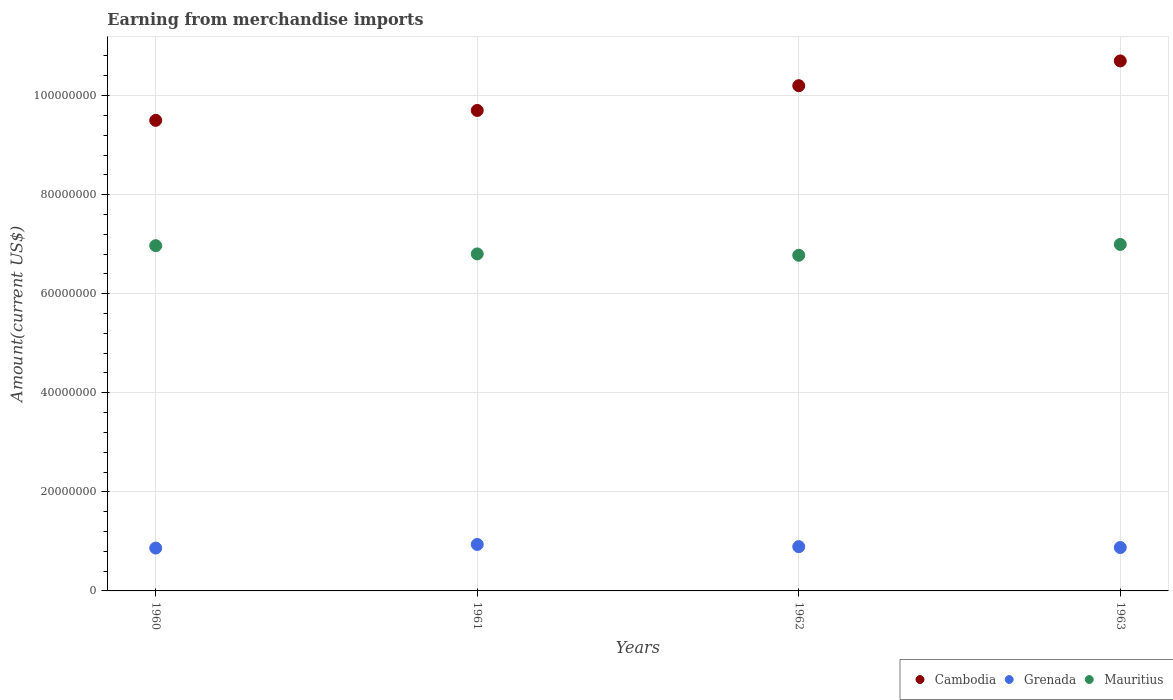How many different coloured dotlines are there?
Offer a very short reply. 3. What is the amount earned from merchandise imports in Mauritius in 1960?
Provide a short and direct response. 6.97e+07. Across all years, what is the maximum amount earned from merchandise imports in Cambodia?
Your answer should be very brief. 1.07e+08. Across all years, what is the minimum amount earned from merchandise imports in Cambodia?
Your answer should be compact. 9.50e+07. In which year was the amount earned from merchandise imports in Mauritius maximum?
Ensure brevity in your answer.  1963. What is the total amount earned from merchandise imports in Grenada in the graph?
Provide a succinct answer. 3.57e+07. What is the difference between the amount earned from merchandise imports in Cambodia in 1960 and that in 1963?
Your answer should be very brief. -1.20e+07. What is the difference between the amount earned from merchandise imports in Grenada in 1962 and the amount earned from merchandise imports in Cambodia in 1963?
Give a very brief answer. -9.81e+07. What is the average amount earned from merchandise imports in Cambodia per year?
Your response must be concise. 1.00e+08. In the year 1960, what is the difference between the amount earned from merchandise imports in Mauritius and amount earned from merchandise imports in Grenada?
Provide a short and direct response. 6.10e+07. In how many years, is the amount earned from merchandise imports in Cambodia greater than 100000000 US$?
Provide a short and direct response. 2. What is the ratio of the amount earned from merchandise imports in Cambodia in 1960 to that in 1961?
Provide a succinct answer. 0.98. Is the amount earned from merchandise imports in Cambodia in 1961 less than that in 1963?
Keep it short and to the point. Yes. What is the difference between the highest and the second highest amount earned from merchandise imports in Mauritius?
Provide a succinct answer. 2.52e+05. What is the difference between the highest and the lowest amount earned from merchandise imports in Mauritius?
Offer a very short reply. 2.18e+06. In how many years, is the amount earned from merchandise imports in Cambodia greater than the average amount earned from merchandise imports in Cambodia taken over all years?
Your response must be concise. 2. Is the sum of the amount earned from merchandise imports in Grenada in 1960 and 1962 greater than the maximum amount earned from merchandise imports in Cambodia across all years?
Your response must be concise. No. Does the amount earned from merchandise imports in Mauritius monotonically increase over the years?
Offer a terse response. No. Is the amount earned from merchandise imports in Grenada strictly greater than the amount earned from merchandise imports in Cambodia over the years?
Offer a very short reply. No. Is the amount earned from merchandise imports in Mauritius strictly less than the amount earned from merchandise imports in Cambodia over the years?
Make the answer very short. Yes. How many dotlines are there?
Keep it short and to the point. 3. What is the difference between two consecutive major ticks on the Y-axis?
Offer a terse response. 2.00e+07. Does the graph contain any zero values?
Offer a terse response. No. How many legend labels are there?
Your answer should be compact. 3. How are the legend labels stacked?
Offer a very short reply. Horizontal. What is the title of the graph?
Give a very brief answer. Earning from merchandise imports. Does "Uruguay" appear as one of the legend labels in the graph?
Your answer should be compact. No. What is the label or title of the X-axis?
Provide a short and direct response. Years. What is the label or title of the Y-axis?
Your response must be concise. Amount(current US$). What is the Amount(current US$) in Cambodia in 1960?
Provide a short and direct response. 9.50e+07. What is the Amount(current US$) in Grenada in 1960?
Provide a succinct answer. 8.65e+06. What is the Amount(current US$) of Mauritius in 1960?
Offer a terse response. 6.97e+07. What is the Amount(current US$) in Cambodia in 1961?
Provide a short and direct response. 9.70e+07. What is the Amount(current US$) in Grenada in 1961?
Provide a succinct answer. 9.38e+06. What is the Amount(current US$) in Mauritius in 1961?
Make the answer very short. 6.80e+07. What is the Amount(current US$) in Cambodia in 1962?
Your response must be concise. 1.02e+08. What is the Amount(current US$) of Grenada in 1962?
Your response must be concise. 8.94e+06. What is the Amount(current US$) of Mauritius in 1962?
Offer a terse response. 6.78e+07. What is the Amount(current US$) of Cambodia in 1963?
Keep it short and to the point. 1.07e+08. What is the Amount(current US$) in Grenada in 1963?
Your answer should be compact. 8.76e+06. What is the Amount(current US$) of Mauritius in 1963?
Keep it short and to the point. 7.00e+07. Across all years, what is the maximum Amount(current US$) in Cambodia?
Keep it short and to the point. 1.07e+08. Across all years, what is the maximum Amount(current US$) in Grenada?
Ensure brevity in your answer.  9.38e+06. Across all years, what is the maximum Amount(current US$) in Mauritius?
Your response must be concise. 7.00e+07. Across all years, what is the minimum Amount(current US$) of Cambodia?
Your response must be concise. 9.50e+07. Across all years, what is the minimum Amount(current US$) of Grenada?
Make the answer very short. 8.65e+06. Across all years, what is the minimum Amount(current US$) of Mauritius?
Offer a very short reply. 6.78e+07. What is the total Amount(current US$) of Cambodia in the graph?
Ensure brevity in your answer.  4.01e+08. What is the total Amount(current US$) of Grenada in the graph?
Provide a succinct answer. 3.57e+07. What is the total Amount(current US$) in Mauritius in the graph?
Your answer should be very brief. 2.75e+08. What is the difference between the Amount(current US$) in Grenada in 1960 and that in 1961?
Your answer should be very brief. -7.30e+05. What is the difference between the Amount(current US$) in Mauritius in 1960 and that in 1961?
Your answer should be compact. 1.66e+06. What is the difference between the Amount(current US$) of Cambodia in 1960 and that in 1962?
Ensure brevity in your answer.  -7.00e+06. What is the difference between the Amount(current US$) of Grenada in 1960 and that in 1962?
Your answer should be compact. -2.84e+05. What is the difference between the Amount(current US$) of Mauritius in 1960 and that in 1962?
Your response must be concise. 1.93e+06. What is the difference between the Amount(current US$) in Cambodia in 1960 and that in 1963?
Your response must be concise. -1.20e+07. What is the difference between the Amount(current US$) of Grenada in 1960 and that in 1963?
Provide a succinct answer. -1.12e+05. What is the difference between the Amount(current US$) of Mauritius in 1960 and that in 1963?
Your response must be concise. -2.52e+05. What is the difference between the Amount(current US$) of Cambodia in 1961 and that in 1962?
Your answer should be very brief. -5.00e+06. What is the difference between the Amount(current US$) of Grenada in 1961 and that in 1962?
Keep it short and to the point. 4.46e+05. What is the difference between the Amount(current US$) in Mauritius in 1961 and that in 1962?
Give a very brief answer. 2.73e+05. What is the difference between the Amount(current US$) in Cambodia in 1961 and that in 1963?
Provide a succinct answer. -1.00e+07. What is the difference between the Amount(current US$) of Grenada in 1961 and that in 1963?
Provide a succinct answer. 6.18e+05. What is the difference between the Amount(current US$) in Mauritius in 1961 and that in 1963?
Offer a very short reply. -1.91e+06. What is the difference between the Amount(current US$) in Cambodia in 1962 and that in 1963?
Your response must be concise. -5.00e+06. What is the difference between the Amount(current US$) of Grenada in 1962 and that in 1963?
Provide a succinct answer. 1.72e+05. What is the difference between the Amount(current US$) of Mauritius in 1962 and that in 1963?
Ensure brevity in your answer.  -2.18e+06. What is the difference between the Amount(current US$) of Cambodia in 1960 and the Amount(current US$) of Grenada in 1961?
Give a very brief answer. 8.56e+07. What is the difference between the Amount(current US$) in Cambodia in 1960 and the Amount(current US$) in Mauritius in 1961?
Provide a succinct answer. 2.70e+07. What is the difference between the Amount(current US$) in Grenada in 1960 and the Amount(current US$) in Mauritius in 1961?
Provide a short and direct response. -5.94e+07. What is the difference between the Amount(current US$) in Cambodia in 1960 and the Amount(current US$) in Grenada in 1962?
Ensure brevity in your answer.  8.61e+07. What is the difference between the Amount(current US$) of Cambodia in 1960 and the Amount(current US$) of Mauritius in 1962?
Provide a succinct answer. 2.72e+07. What is the difference between the Amount(current US$) in Grenada in 1960 and the Amount(current US$) in Mauritius in 1962?
Give a very brief answer. -5.91e+07. What is the difference between the Amount(current US$) of Cambodia in 1960 and the Amount(current US$) of Grenada in 1963?
Your answer should be very brief. 8.62e+07. What is the difference between the Amount(current US$) of Cambodia in 1960 and the Amount(current US$) of Mauritius in 1963?
Your answer should be very brief. 2.50e+07. What is the difference between the Amount(current US$) in Grenada in 1960 and the Amount(current US$) in Mauritius in 1963?
Offer a terse response. -6.13e+07. What is the difference between the Amount(current US$) in Cambodia in 1961 and the Amount(current US$) in Grenada in 1962?
Make the answer very short. 8.81e+07. What is the difference between the Amount(current US$) of Cambodia in 1961 and the Amount(current US$) of Mauritius in 1962?
Your answer should be very brief. 2.92e+07. What is the difference between the Amount(current US$) of Grenada in 1961 and the Amount(current US$) of Mauritius in 1962?
Ensure brevity in your answer.  -5.84e+07. What is the difference between the Amount(current US$) of Cambodia in 1961 and the Amount(current US$) of Grenada in 1963?
Offer a very short reply. 8.82e+07. What is the difference between the Amount(current US$) in Cambodia in 1961 and the Amount(current US$) in Mauritius in 1963?
Give a very brief answer. 2.70e+07. What is the difference between the Amount(current US$) of Grenada in 1961 and the Amount(current US$) of Mauritius in 1963?
Ensure brevity in your answer.  -6.06e+07. What is the difference between the Amount(current US$) of Cambodia in 1962 and the Amount(current US$) of Grenada in 1963?
Your answer should be compact. 9.32e+07. What is the difference between the Amount(current US$) in Cambodia in 1962 and the Amount(current US$) in Mauritius in 1963?
Provide a short and direct response. 3.20e+07. What is the difference between the Amount(current US$) in Grenada in 1962 and the Amount(current US$) in Mauritius in 1963?
Ensure brevity in your answer.  -6.10e+07. What is the average Amount(current US$) of Cambodia per year?
Make the answer very short. 1.00e+08. What is the average Amount(current US$) in Grenada per year?
Keep it short and to the point. 8.93e+06. What is the average Amount(current US$) of Mauritius per year?
Give a very brief answer. 6.89e+07. In the year 1960, what is the difference between the Amount(current US$) in Cambodia and Amount(current US$) in Grenada?
Keep it short and to the point. 8.63e+07. In the year 1960, what is the difference between the Amount(current US$) in Cambodia and Amount(current US$) in Mauritius?
Your answer should be very brief. 2.53e+07. In the year 1960, what is the difference between the Amount(current US$) in Grenada and Amount(current US$) in Mauritius?
Offer a terse response. -6.10e+07. In the year 1961, what is the difference between the Amount(current US$) of Cambodia and Amount(current US$) of Grenada?
Make the answer very short. 8.76e+07. In the year 1961, what is the difference between the Amount(current US$) of Cambodia and Amount(current US$) of Mauritius?
Provide a succinct answer. 2.90e+07. In the year 1961, what is the difference between the Amount(current US$) in Grenada and Amount(current US$) in Mauritius?
Ensure brevity in your answer.  -5.87e+07. In the year 1962, what is the difference between the Amount(current US$) of Cambodia and Amount(current US$) of Grenada?
Your answer should be very brief. 9.31e+07. In the year 1962, what is the difference between the Amount(current US$) of Cambodia and Amount(current US$) of Mauritius?
Provide a short and direct response. 3.42e+07. In the year 1962, what is the difference between the Amount(current US$) in Grenada and Amount(current US$) in Mauritius?
Offer a very short reply. -5.88e+07. In the year 1963, what is the difference between the Amount(current US$) of Cambodia and Amount(current US$) of Grenada?
Make the answer very short. 9.82e+07. In the year 1963, what is the difference between the Amount(current US$) of Cambodia and Amount(current US$) of Mauritius?
Your response must be concise. 3.70e+07. In the year 1963, what is the difference between the Amount(current US$) in Grenada and Amount(current US$) in Mauritius?
Give a very brief answer. -6.12e+07. What is the ratio of the Amount(current US$) in Cambodia in 1960 to that in 1961?
Make the answer very short. 0.98. What is the ratio of the Amount(current US$) in Grenada in 1960 to that in 1961?
Your answer should be compact. 0.92. What is the ratio of the Amount(current US$) of Mauritius in 1960 to that in 1961?
Ensure brevity in your answer.  1.02. What is the ratio of the Amount(current US$) of Cambodia in 1960 to that in 1962?
Ensure brevity in your answer.  0.93. What is the ratio of the Amount(current US$) of Grenada in 1960 to that in 1962?
Provide a short and direct response. 0.97. What is the ratio of the Amount(current US$) in Mauritius in 1960 to that in 1962?
Ensure brevity in your answer.  1.03. What is the ratio of the Amount(current US$) of Cambodia in 1960 to that in 1963?
Your answer should be very brief. 0.89. What is the ratio of the Amount(current US$) in Grenada in 1960 to that in 1963?
Your answer should be compact. 0.99. What is the ratio of the Amount(current US$) in Cambodia in 1961 to that in 1962?
Your answer should be compact. 0.95. What is the ratio of the Amount(current US$) of Grenada in 1961 to that in 1962?
Your response must be concise. 1.05. What is the ratio of the Amount(current US$) in Cambodia in 1961 to that in 1963?
Offer a terse response. 0.91. What is the ratio of the Amount(current US$) of Grenada in 1961 to that in 1963?
Keep it short and to the point. 1.07. What is the ratio of the Amount(current US$) of Mauritius in 1961 to that in 1963?
Offer a terse response. 0.97. What is the ratio of the Amount(current US$) in Cambodia in 1962 to that in 1963?
Provide a short and direct response. 0.95. What is the ratio of the Amount(current US$) of Grenada in 1962 to that in 1963?
Give a very brief answer. 1.02. What is the ratio of the Amount(current US$) in Mauritius in 1962 to that in 1963?
Ensure brevity in your answer.  0.97. What is the difference between the highest and the second highest Amount(current US$) of Cambodia?
Make the answer very short. 5.00e+06. What is the difference between the highest and the second highest Amount(current US$) of Grenada?
Your response must be concise. 4.46e+05. What is the difference between the highest and the second highest Amount(current US$) in Mauritius?
Offer a terse response. 2.52e+05. What is the difference between the highest and the lowest Amount(current US$) in Grenada?
Provide a succinct answer. 7.30e+05. What is the difference between the highest and the lowest Amount(current US$) in Mauritius?
Provide a short and direct response. 2.18e+06. 